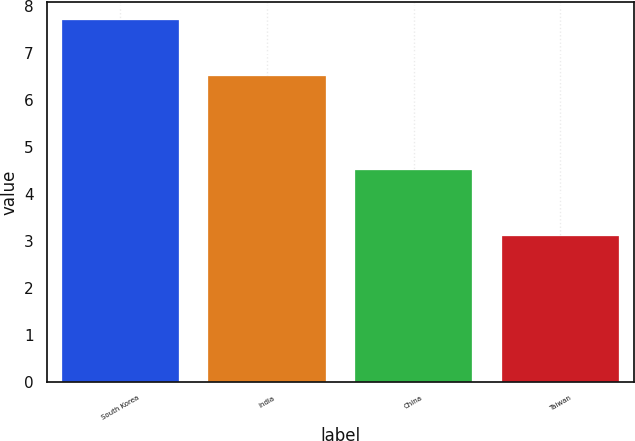Convert chart to OTSL. <chart><loc_0><loc_0><loc_500><loc_500><bar_chart><fcel>South Korea<fcel>India<fcel>China<fcel>Taiwan<nl><fcel>7.7<fcel>6.5<fcel>4.5<fcel>3.1<nl></chart> 